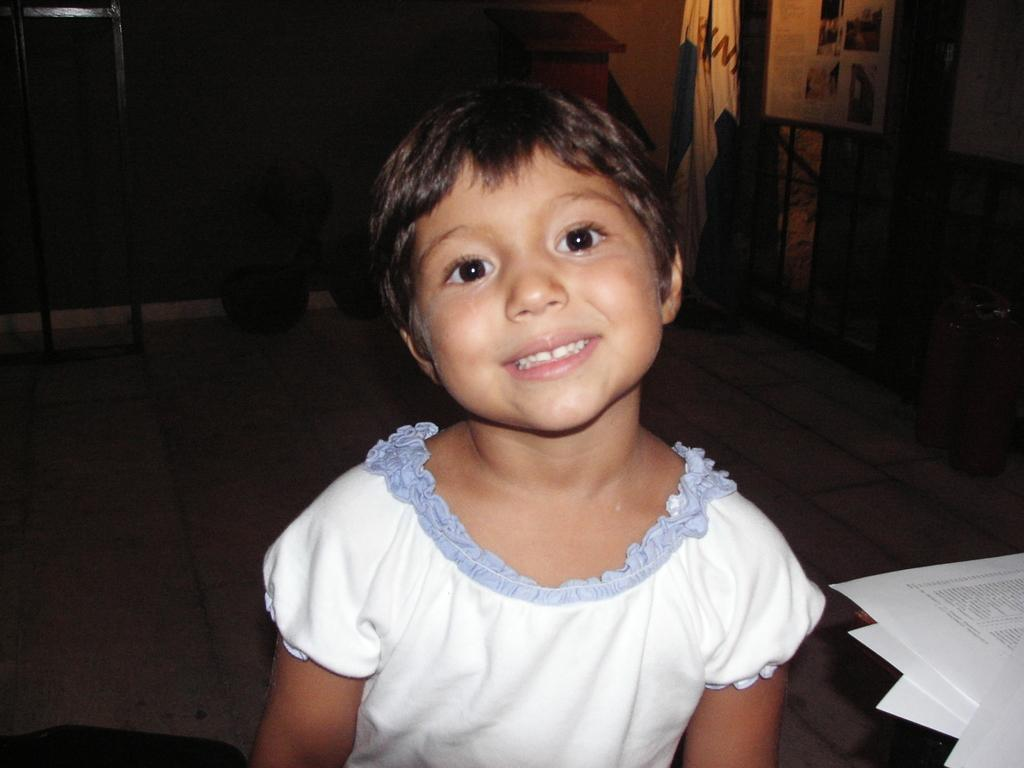What is the overall color scheme of the image? The background of the image is dark. What is the main object in the image? There is a board in the image. What else can be seen in the image besides the board? There are objects and papers in the image. How is the girl in the image feeling? The girl is smiling in the image. What type of bath can be seen in the image? There is no bath present in the image. What is the value of the objects in the image? The value of the objects in the image cannot be determined from the image alone. 